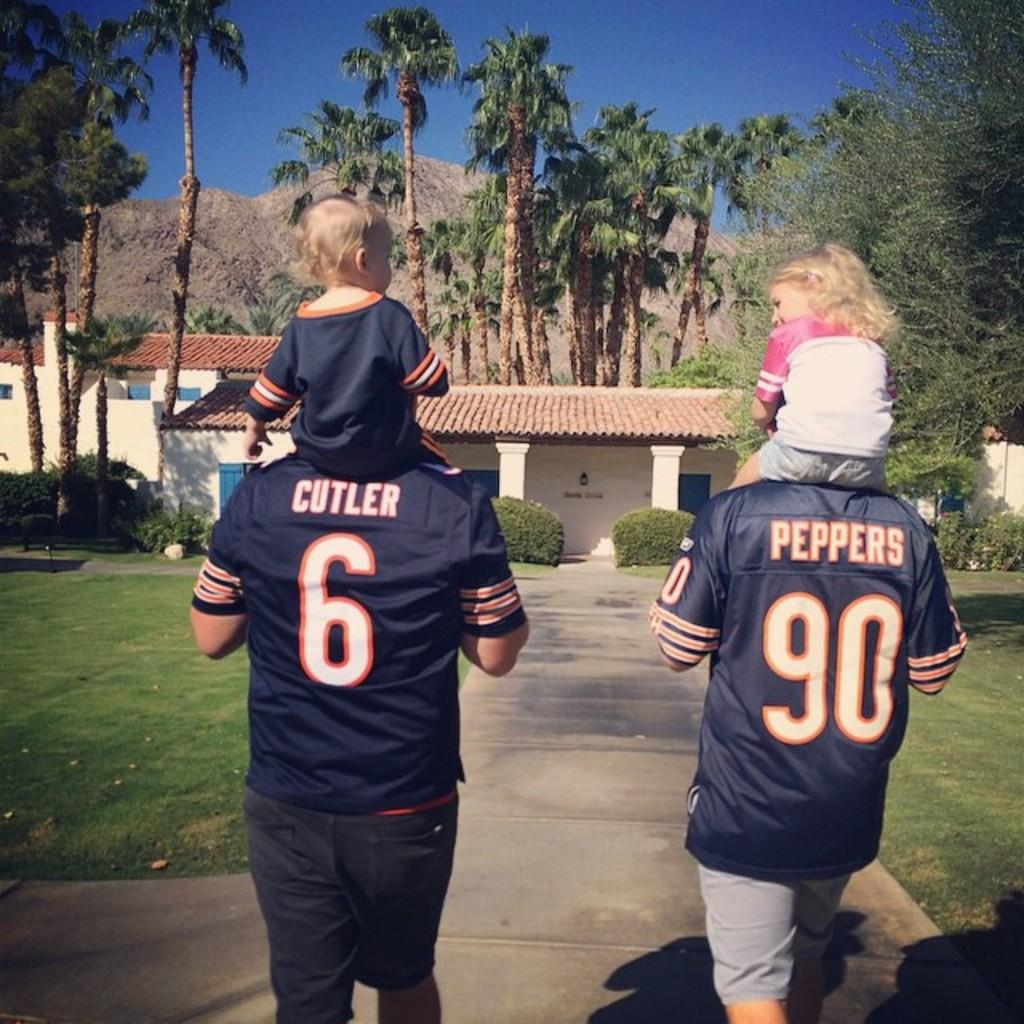<image>
Render a clear and concise summary of the photo. a couple of people with one of them that has the name Peppers on their jersey 